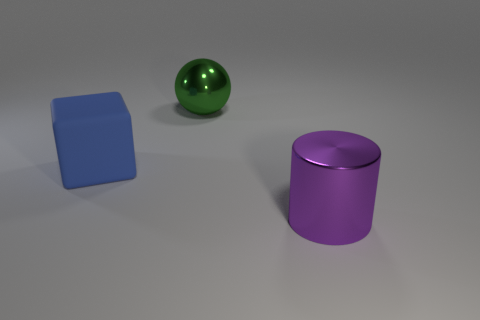There is a object that is to the right of the shiny object behind the purple metallic thing; what number of big blue cubes are in front of it?
Your answer should be compact. 0. What size is the green ball that is made of the same material as the purple cylinder?
Offer a very short reply. Large. What is the shape of the large thing that is left of the purple shiny cylinder and to the right of the cube?
Ensure brevity in your answer.  Sphere. Are there the same number of large matte blocks that are on the right side of the big green shiny thing and green rubber cylinders?
Your response must be concise. Yes. How many objects are either green objects or large things behind the large purple shiny object?
Provide a succinct answer. 2. Is there another big metallic thing that has the same shape as the big blue object?
Offer a very short reply. No. Is the number of blue objects on the left side of the metal ball the same as the number of big metallic objects in front of the large metallic cylinder?
Your response must be concise. No. How many purple things are cylinders or blocks?
Offer a very short reply. 1. What number of rubber objects have the same size as the block?
Give a very brief answer. 0. There is a large object that is on the right side of the big matte block and on the left side of the large purple metallic thing; what is its color?
Your answer should be very brief. Green. 